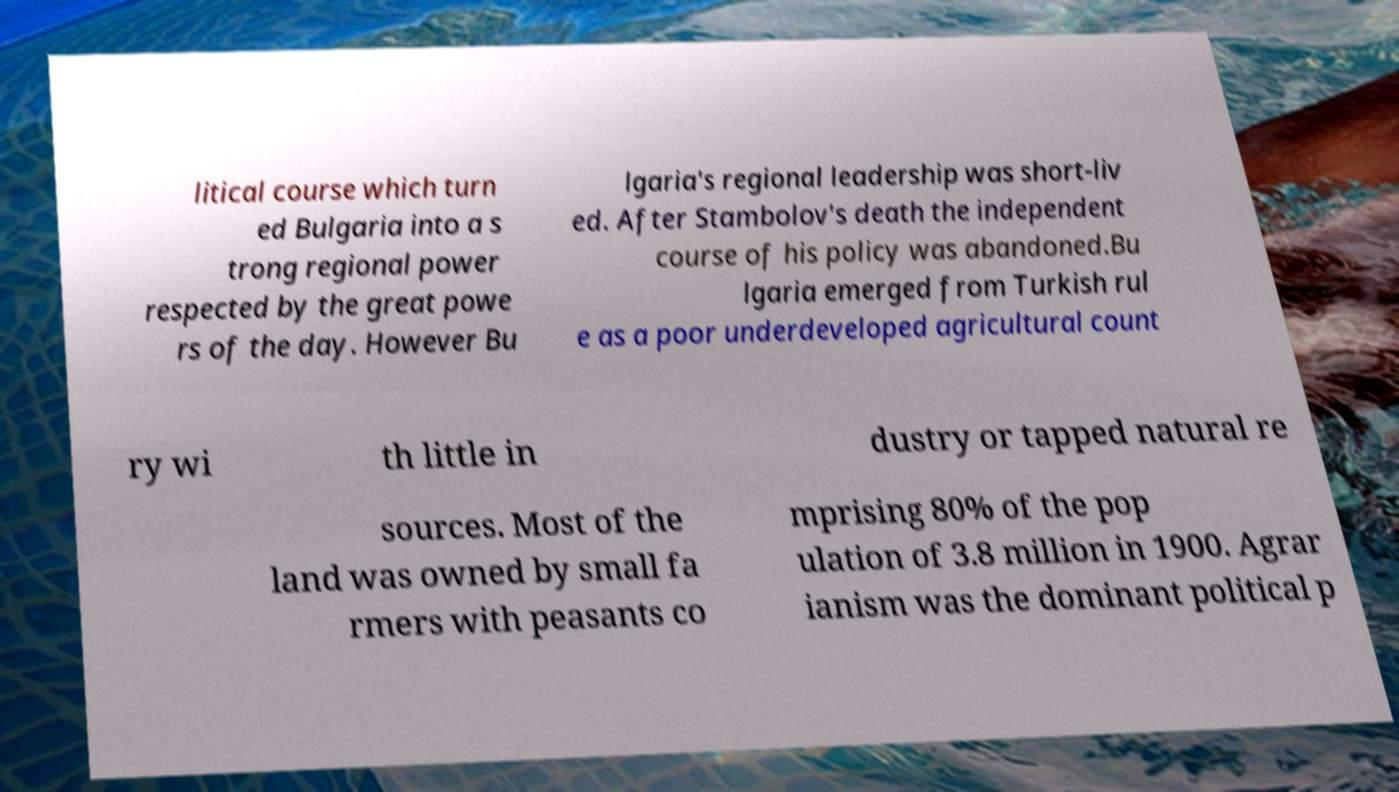Can you accurately transcribe the text from the provided image for me? litical course which turn ed Bulgaria into a s trong regional power respected by the great powe rs of the day. However Bu lgaria's regional leadership was short-liv ed. After Stambolov's death the independent course of his policy was abandoned.Bu lgaria emerged from Turkish rul e as a poor underdeveloped agricultural count ry wi th little in dustry or tapped natural re sources. Most of the land was owned by small fa rmers with peasants co mprising 80% of the pop ulation of 3.8 million in 1900. Agrar ianism was the dominant political p 